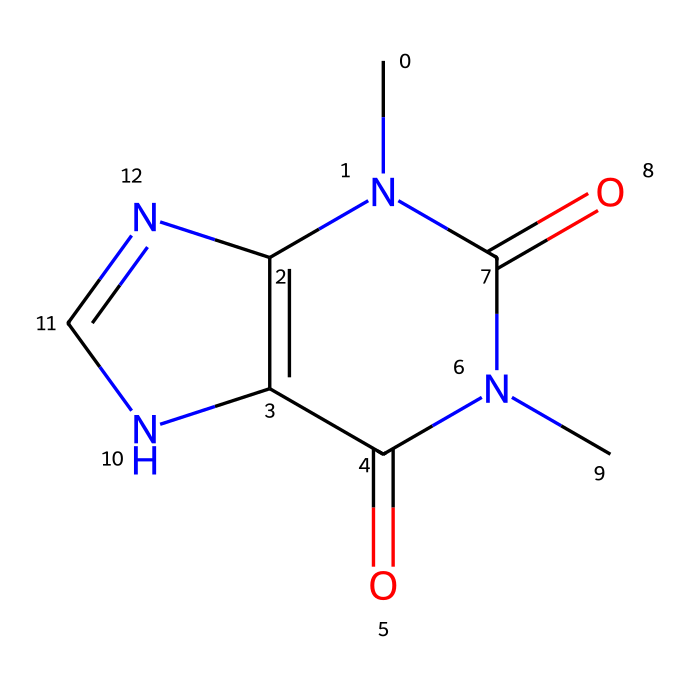What is the molecular formula of this compound? To determine the molecular formula, we can count the number of each type of atom represented by the chemical structure's atoms. The structure is CN1C2=C(C(=O)N(C1=O)C)NC=N2. This indicates we have carbon (C), hydrogen (H), nitrogen (N), and oxygen (O) atoms present. Counting gives C5, H6, N4, and O2. Therefore, the molecular formula is C5H6N4O2.
Answer: C5H6N4O2 How many nitrogen atoms are present in the structure? By analyzing the SMILES representation, we can count the nitrogen (N) atoms directly. Here, nitrogen appears four times: in the parts CN1, N(C1=O), and NC=N2. Hence, there are four nitrogen atoms.
Answer: 4 What functional groups are present in the chemical structure? The chemical structure contains amine (due to nitrogen atoms), carbonyl (C=O), and imine groups (C=N). These functional groups can be identified based on the arrangement of atoms.
Answer: amine, carbonyl, imine Which atom has a double bond with oxygen? The presence of the carbonyl groups suggests that certain carbon atoms double bond with oxygen (C=O). In the structure, this is seen in C(=O) and N(C1=O). Thus, two double bonds involve oxygen atoms.
Answer: carbon Is this structure likely to be hydrophilic or hydrophobic? Considering the presence of multiple nitrogen and oxygen atoms (which tend to be polar), the structure is likely hydrophilic as these functional groups can interact well with water. This indicates that the chemical is more soluble in water than in non-polar solvents.
Answer: hydrophilic 